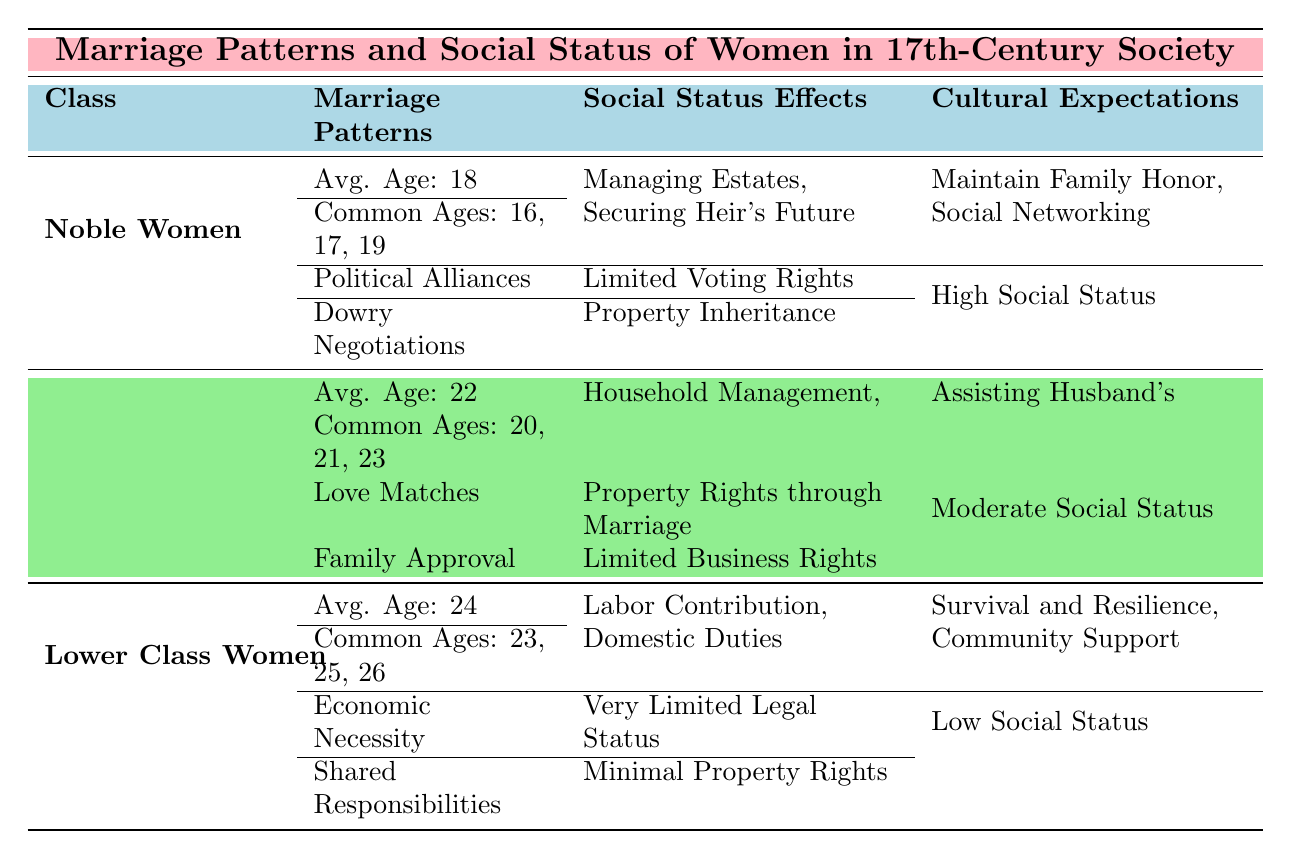What is the average age at marriage for Noble Women? From the table under the Noble Women section, the average age at marriage is explicitly stated to be 18.
Answer: 18 What are the common ages at marriage for Middle Class Women? The table lists the common ages at marriage for Middle Class Women as 20, 21, and 23.
Answer: 20, 21, 23 Do Lower Class Women have any property rights? The table indicates that Lower Class Women have very limited legal status and minimal property rights, which implies they have no significant property rights.
Answer: No What social status do Middle Class Women hold compared to Noble Women? By observing the social status column, Middle Class Women are noted to have a moderate social status while Noble Women have a high social status, indicating that Noble Women have a higher social status.
Answer: Noble Women have a higher social status What is the difference in average age at marriage between Lower Class Women and Noble Women? The average age for Lower Class Women is 24, while for Noble Women it is 18. The difference is calculated as 24 - 18 = 6.
Answer: 6 What responsibilities do Noble Women have according to the table? The table lists their responsibilities as "Managing Estates" and "Securing Heir's Future."
Answer: Managing Estates, Securing Heir's Future How does the cultural expectation for Lower Class Women differ from that of Noble Women? The cultural expectations for Lower Class Women focus on "Survival and Resilience, Community Support," while for Noble Women, it emphasizes "Maintain Family Honor, Social Networking." These expectations highlight a significant contrast in societal roles.
Answer: Different; Noble Women focus on honor and networking, Lower Class Women on survival and community Are the marriage arrangements for Middle Class Women based more on love or economic necessity? The table indicates that Middle Class Women often have "Love Matches" and "Family Approval," suggesting a focus on love rather than economic necessity, which is common for Lower Class Women.
Answer: Based more on love What is the relationship between age at marriage and social status in this table? Analyzing the data shows that higher social status (Noble Women) corresponds to a younger age at marriage (average 18) compared to lower social status (Lower Class Women), who marry later (average 24). This indicates that social status may influence age at marriage significantly.
Answer: Higher social status correlates with younger age at marriage 